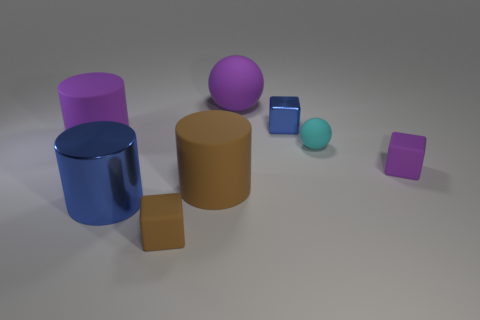Add 1 blue balls. How many objects exist? 9 Subtract all cylinders. How many objects are left? 5 Add 2 cyan matte objects. How many cyan matte objects are left? 3 Add 6 yellow cylinders. How many yellow cylinders exist? 6 Subtract 0 green cubes. How many objects are left? 8 Subtract all tiny yellow things. Subtract all purple balls. How many objects are left? 7 